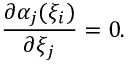<formula> <loc_0><loc_0><loc_500><loc_500>\frac { \partial \alpha _ { j } ( \xi _ { i } ) } { \partial \xi _ { j } } = 0 .</formula> 